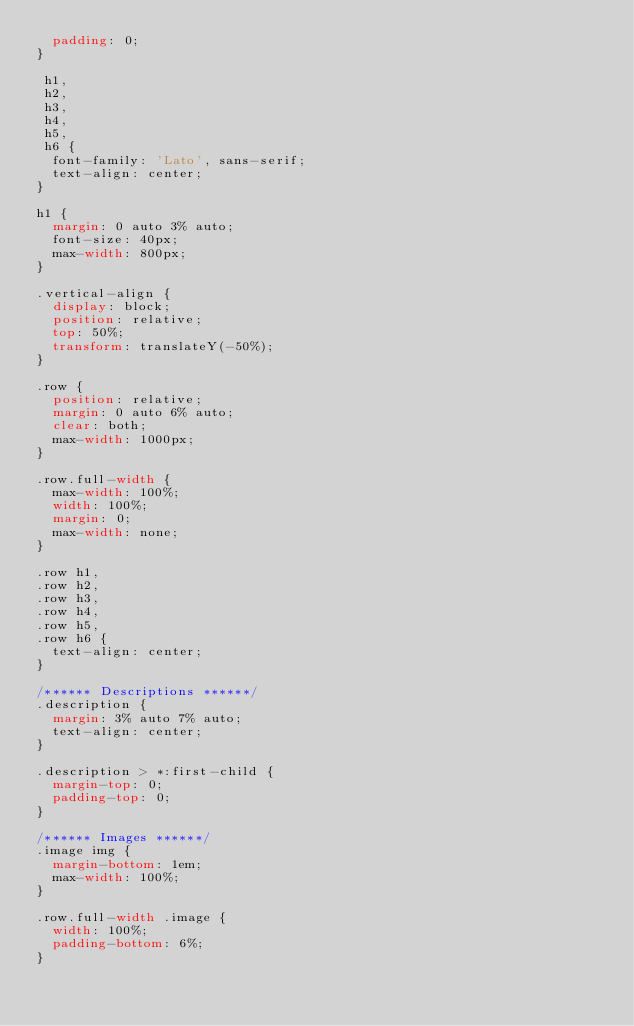Convert code to text. <code><loc_0><loc_0><loc_500><loc_500><_CSS_>  padding: 0;
}

 h1,
 h2,
 h3,
 h4,
 h5,
 h6 {
  font-family: 'Lato', sans-serif;
  text-align: center;
}

h1 {
  margin: 0 auto 3% auto;
  font-size: 40px;
  max-width: 800px;
}

.vertical-align {
  display: block;
  position: relative;
  top: 50%;
  transform: translateY(-50%);
}

.row {
  position: relative;
  margin: 0 auto 6% auto;
  clear: both;
  max-width: 1000px;
}

.row.full-width {
  max-width: 100%;
  width: 100%;
  margin: 0;
  max-width: none;
}

.row h1,
.row h2,
.row h3,
.row h4,
.row h5,
.row h6 {
  text-align: center;
}

/****** Descriptions ******/
.description {
  margin: 3% auto 7% auto;
  text-align: center;
}

.description > *:first-child {
  margin-top: 0;
  padding-top: 0;
}

/****** Images ******/
.image img {
  margin-bottom: 1em;
  max-width: 100%;
}

.row.full-width .image {
  width: 100%;
  padding-bottom: 6%;
}
</code> 